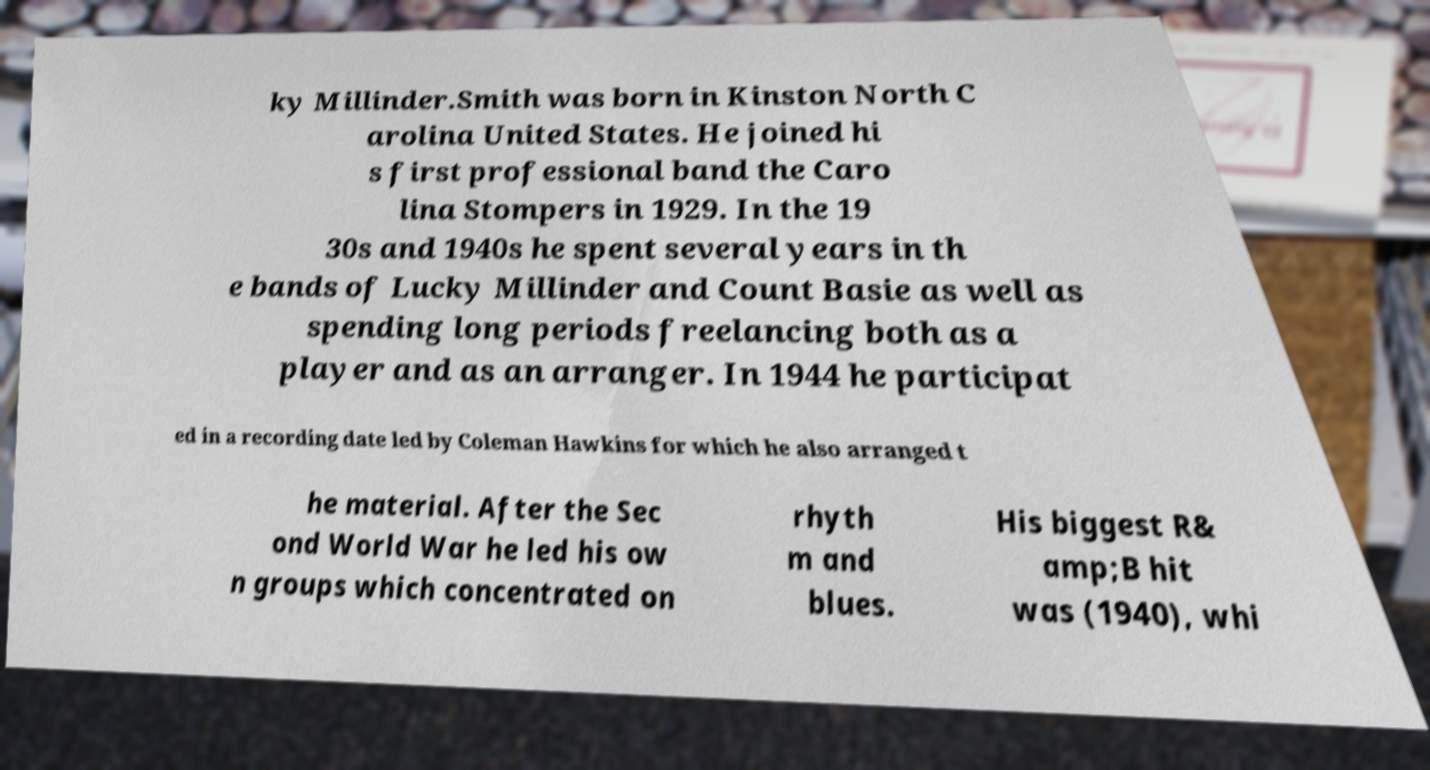I need the written content from this picture converted into text. Can you do that? ky Millinder.Smith was born in Kinston North C arolina United States. He joined hi s first professional band the Caro lina Stompers in 1929. In the 19 30s and 1940s he spent several years in th e bands of Lucky Millinder and Count Basie as well as spending long periods freelancing both as a player and as an arranger. In 1944 he participat ed in a recording date led by Coleman Hawkins for which he also arranged t he material. After the Sec ond World War he led his ow n groups which concentrated on rhyth m and blues. His biggest R& amp;B hit was (1940), whi 